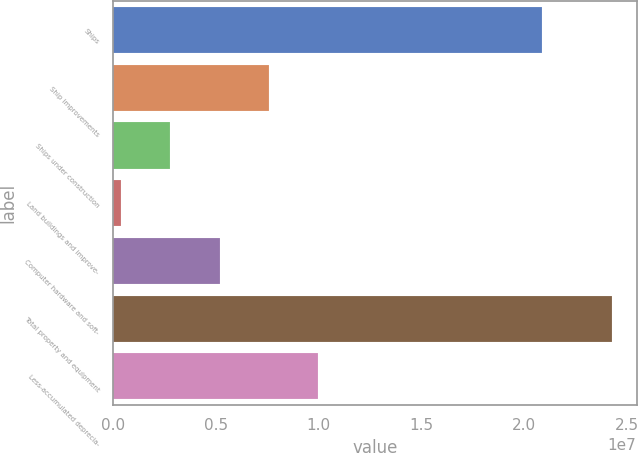<chart> <loc_0><loc_0><loc_500><loc_500><bar_chart><fcel>Ships<fcel>Ship improvements<fcel>Ships under construction<fcel>Land buildings and improve-<fcel>Computer hardware and soft-<fcel>Total property and equipment<fcel>Less-accumulated deprecia-<nl><fcel>2.08586e+07<fcel>7.55727e+06<fcel>2.78184e+06<fcel>394120<fcel>5.16956e+06<fcel>2.42713e+07<fcel>9.94499e+06<nl></chart> 